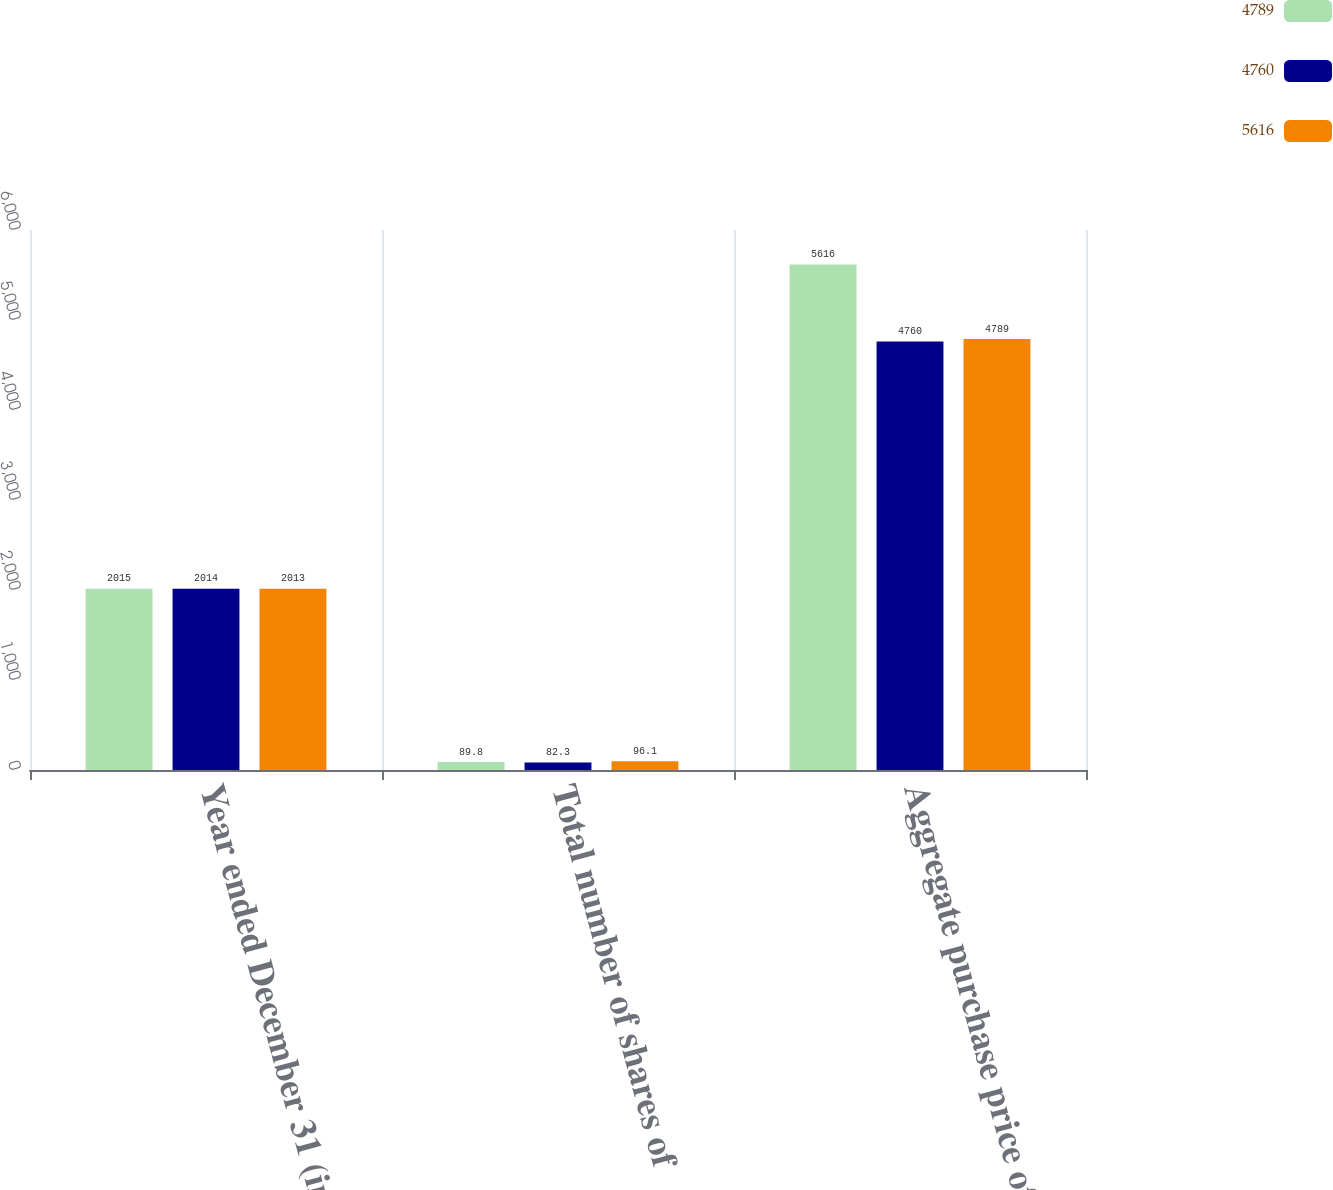Convert chart to OTSL. <chart><loc_0><loc_0><loc_500><loc_500><stacked_bar_chart><ecel><fcel>Year ended December 31 (in<fcel>Total number of shares of<fcel>Aggregate purchase price of<nl><fcel>4789<fcel>2015<fcel>89.8<fcel>5616<nl><fcel>4760<fcel>2014<fcel>82.3<fcel>4760<nl><fcel>5616<fcel>2013<fcel>96.1<fcel>4789<nl></chart> 